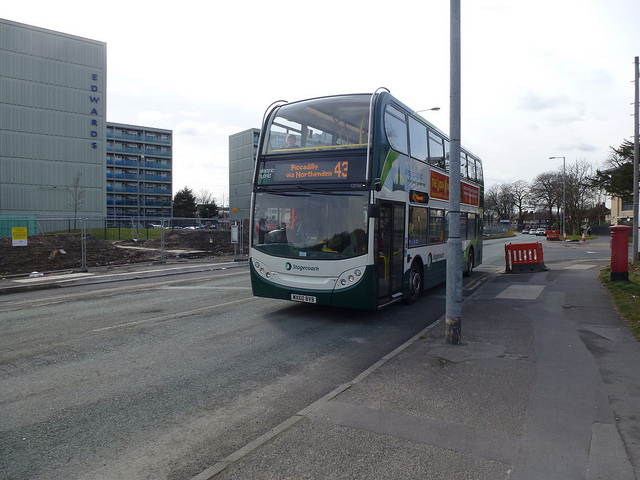Read all the text in this image. 43 EDWARDS 